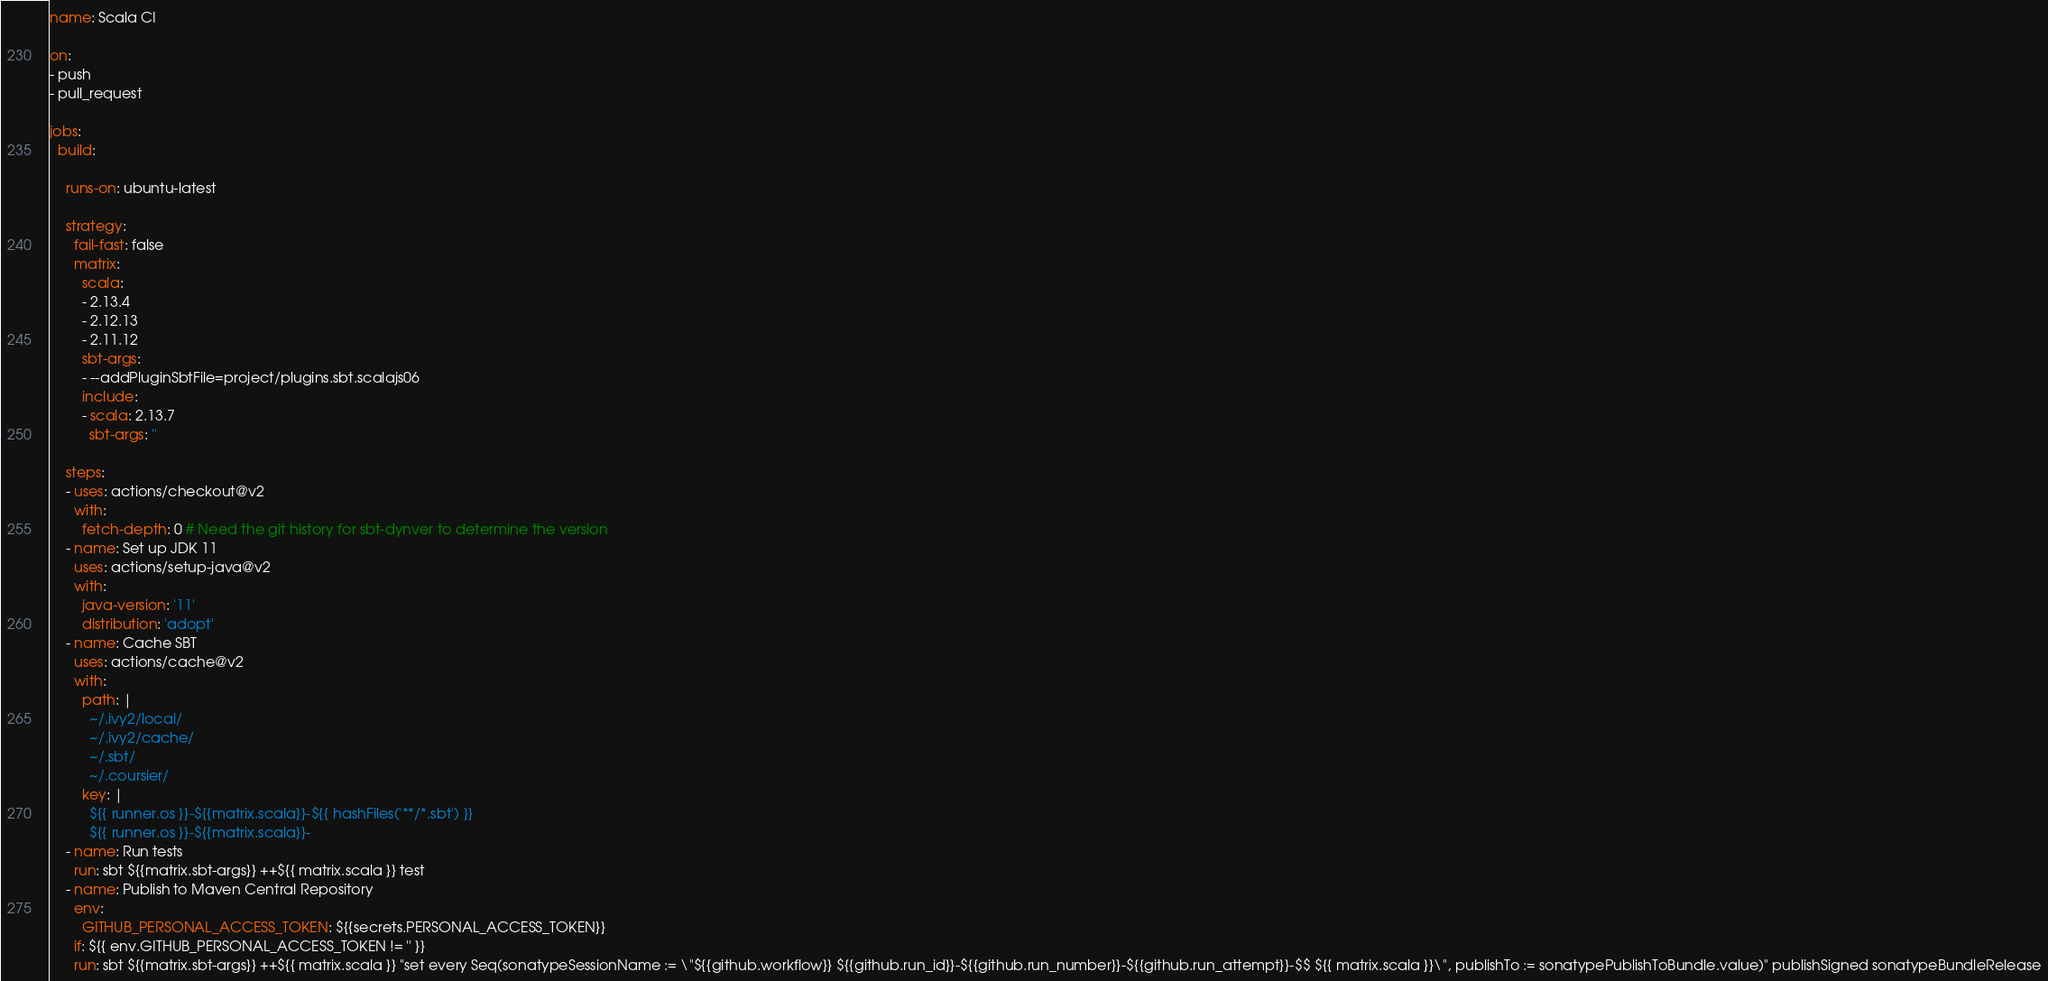Convert code to text. <code><loc_0><loc_0><loc_500><loc_500><_YAML_>name: Scala CI

on:
- push
- pull_request

jobs:
  build:

    runs-on: ubuntu-latest

    strategy:
      fail-fast: false
      matrix:
        scala:
        - 2.13.4
        - 2.12.13
        - 2.11.12
        sbt-args:
        - --addPluginSbtFile=project/plugins.sbt.scalajs06
        include:
        - scala: 2.13.7
          sbt-args: ''

    steps:
    - uses: actions/checkout@v2
      with:
        fetch-depth: 0 # Need the git history for sbt-dynver to determine the version
    - name: Set up JDK 11
      uses: actions/setup-java@v2
      with:
        java-version: '11'
        distribution: 'adopt'
    - name: Cache SBT
      uses: actions/cache@v2
      with:
        path: | 
          ~/.ivy2/local/
          ~/.ivy2/cache/
          ~/.sbt/
          ~/.coursier/
        key: |
          ${{ runner.os }}-${{matrix.scala}}-${{ hashFiles('**/*.sbt') }}
          ${{ runner.os }}-${{matrix.scala}}-
    - name: Run tests
      run: sbt ${{matrix.sbt-args}} ++${{ matrix.scala }} test
    - name: Publish to Maven Central Repository
      env:
        GITHUB_PERSONAL_ACCESS_TOKEN: ${{secrets.PERSONAL_ACCESS_TOKEN}}
      if: ${{ env.GITHUB_PERSONAL_ACCESS_TOKEN != '' }}
      run: sbt ${{matrix.sbt-args}} ++${{ matrix.scala }} "set every Seq(sonatypeSessionName := \"${{github.workflow}} ${{github.run_id}}-${{github.run_number}}-${{github.run_attempt}}-$$ ${{ matrix.scala }}\", publishTo := sonatypePublishToBundle.value)" publishSigned sonatypeBundleRelease
</code> 